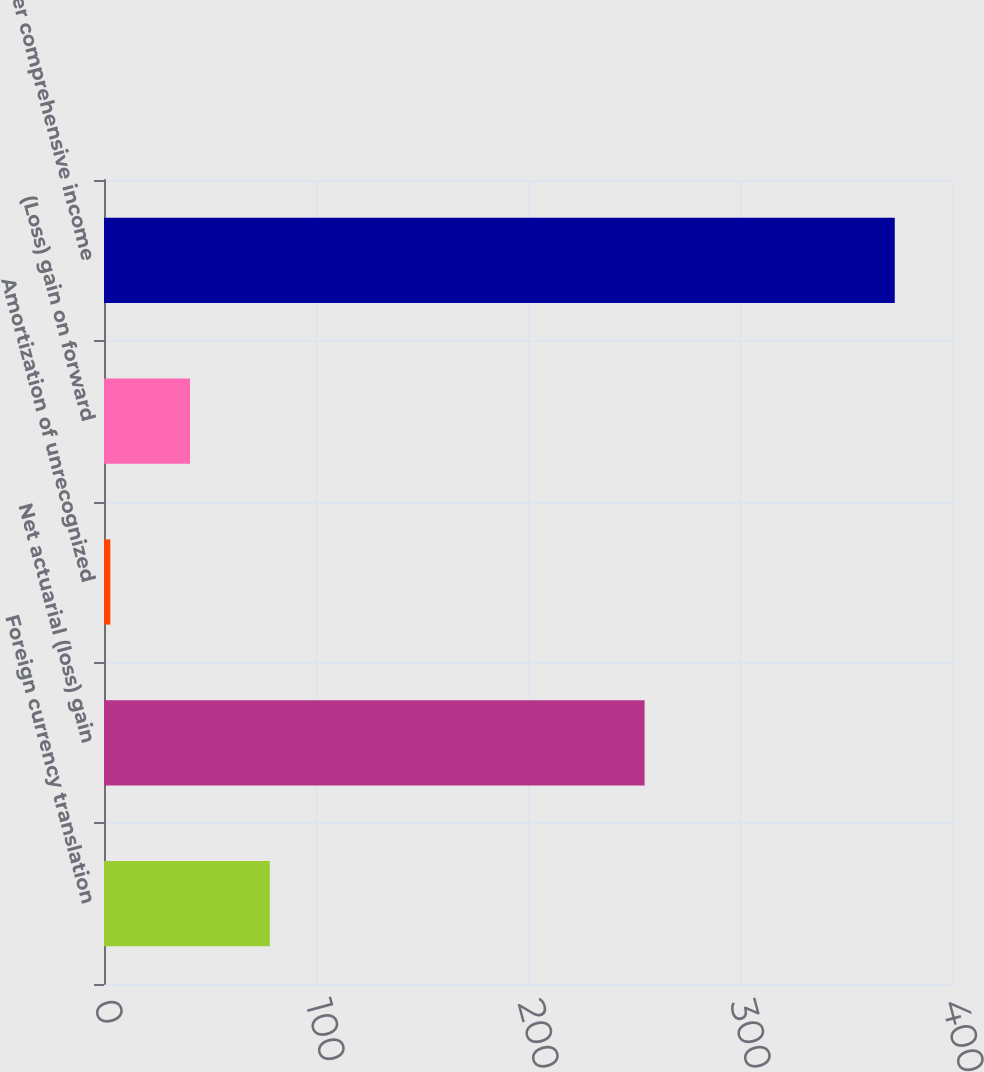<chart> <loc_0><loc_0><loc_500><loc_500><bar_chart><fcel>Foreign currency translation<fcel>Net actuarial (loss) gain<fcel>Amortization of unrecognized<fcel>(Loss) gain on forward<fcel>Other comprehensive income<nl><fcel>78.2<fcel>255<fcel>3<fcel>40.6<fcel>373<nl></chart> 